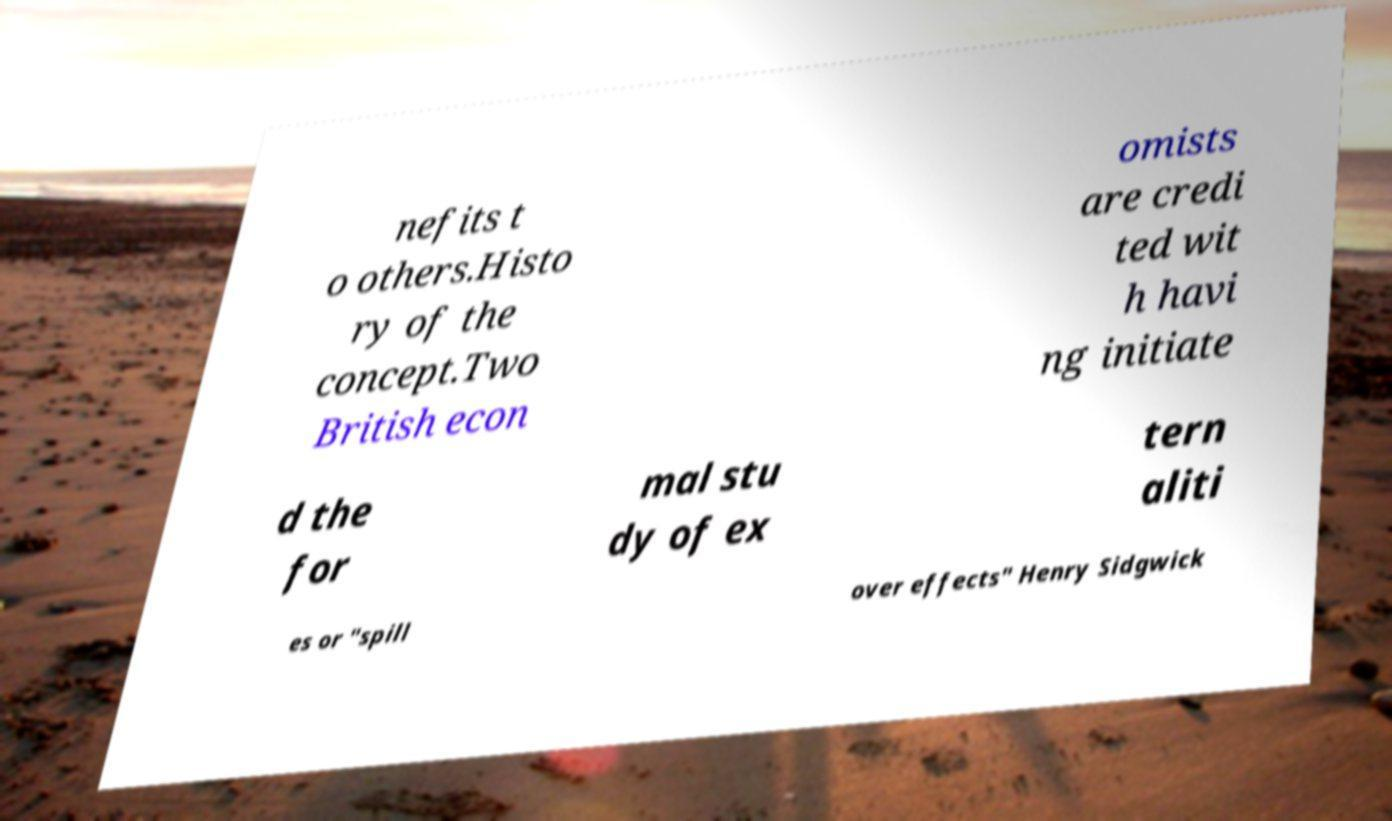There's text embedded in this image that I need extracted. Can you transcribe it verbatim? nefits t o others.Histo ry of the concept.Two British econ omists are credi ted wit h havi ng initiate d the for mal stu dy of ex tern aliti es or "spill over effects" Henry Sidgwick 